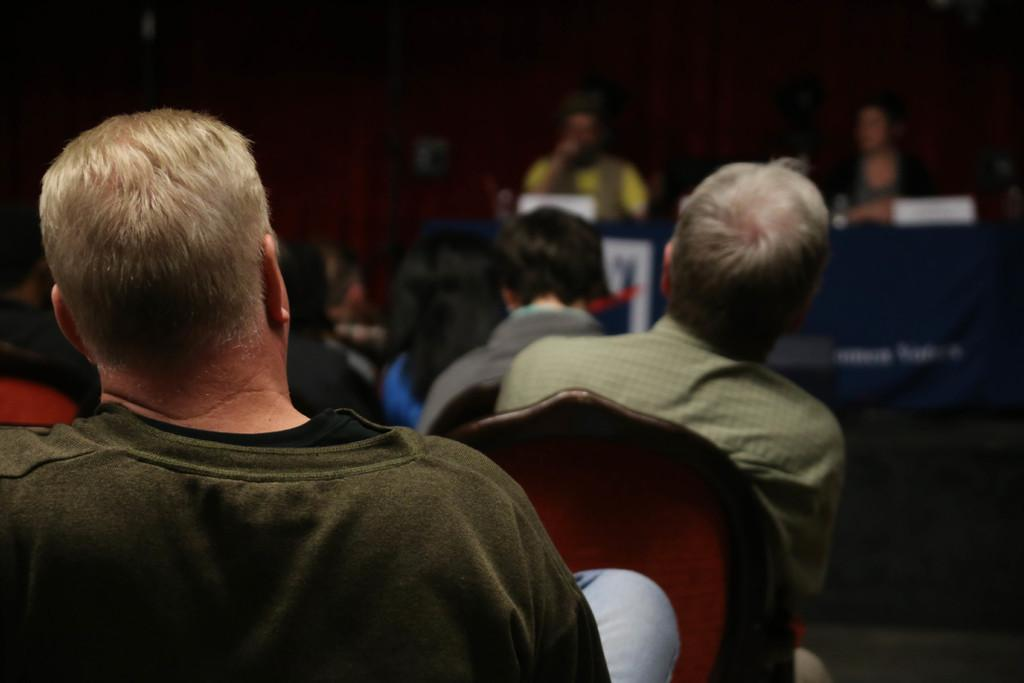What are the persons in the image doing? The persons in the image are sitting on chairs. Where are the persons sitting in relation to the table? The persons are sitting behind a table in the image. What can be seen on the table? There are objects on the table in the image. What is visible in the background of the image? There is a wall visible in the background of the image. What grade of pear is being served on the table in the image? There is no pear present in the image, so it is not possible to determine the grade of any pear. 